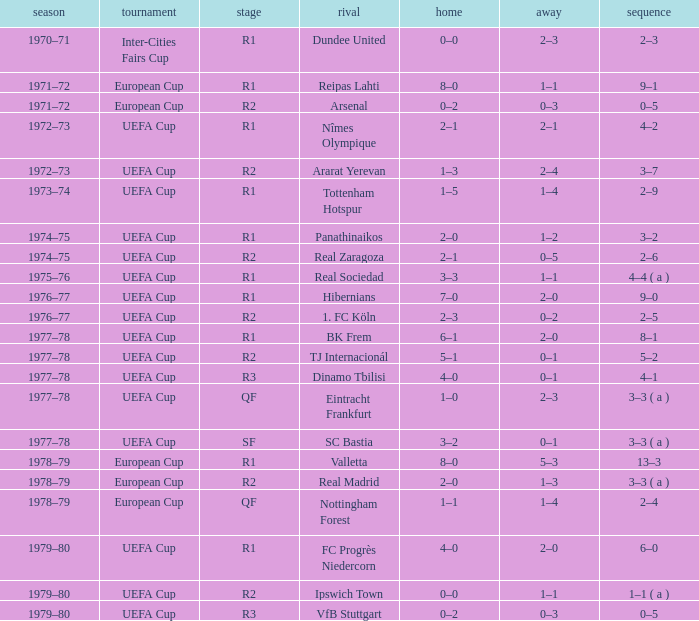Which Series has a Home of 2–0, and an Opponent of panathinaikos? 3–2. 